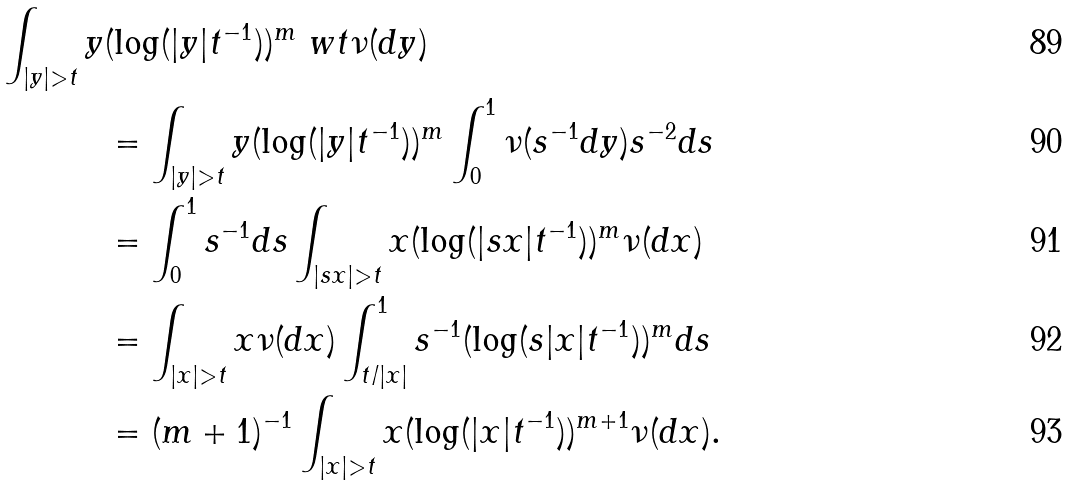<formula> <loc_0><loc_0><loc_500><loc_500>\int _ { | y | > t } y & ( \log ( | y | t ^ { - 1 } ) ) ^ { m } \ w t \nu ( d y ) \\ & = \int _ { | y | > t } y ( \log ( | y | t ^ { - 1 } ) ) ^ { m } \int _ { 0 } ^ { 1 } \nu ( s ^ { - 1 } d y ) s ^ { - 2 } d s \\ & = \int _ { 0 } ^ { 1 } s ^ { - 1 } d s \int _ { | s x | > t } x ( \log ( | s x | t ^ { - 1 } ) ) ^ { m } \nu ( d x ) \\ & = \int _ { | x | > t } x \nu ( d x ) \int _ { t / | x | } ^ { 1 } s ^ { - 1 } ( \log ( s | x | t ^ { - 1 } ) ) ^ { m } d s \\ & = ( { m + 1 } ) ^ { - 1 } \int _ { | x | > t } x ( \log ( | x | t ^ { - 1 } ) ) ^ { m + 1 } \nu ( d x ) .</formula> 